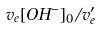Convert formula to latex. <formula><loc_0><loc_0><loc_500><loc_500>v _ { e } [ O H ^ { - } ] _ { 0 } / v _ { e } ^ { \prime }</formula> 